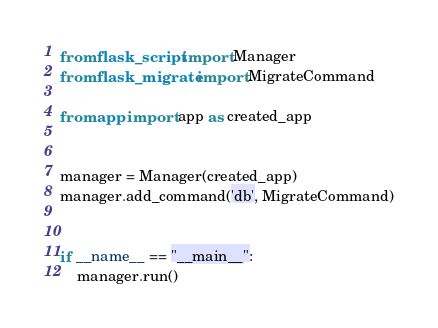<code> <loc_0><loc_0><loc_500><loc_500><_Python_>from flask_script import Manager
from flask_migrate import MigrateCommand

from app import app as created_app


manager = Manager(created_app)
manager.add_command('db', MigrateCommand)


if __name__ == "__main__":
    manager.run()
</code> 